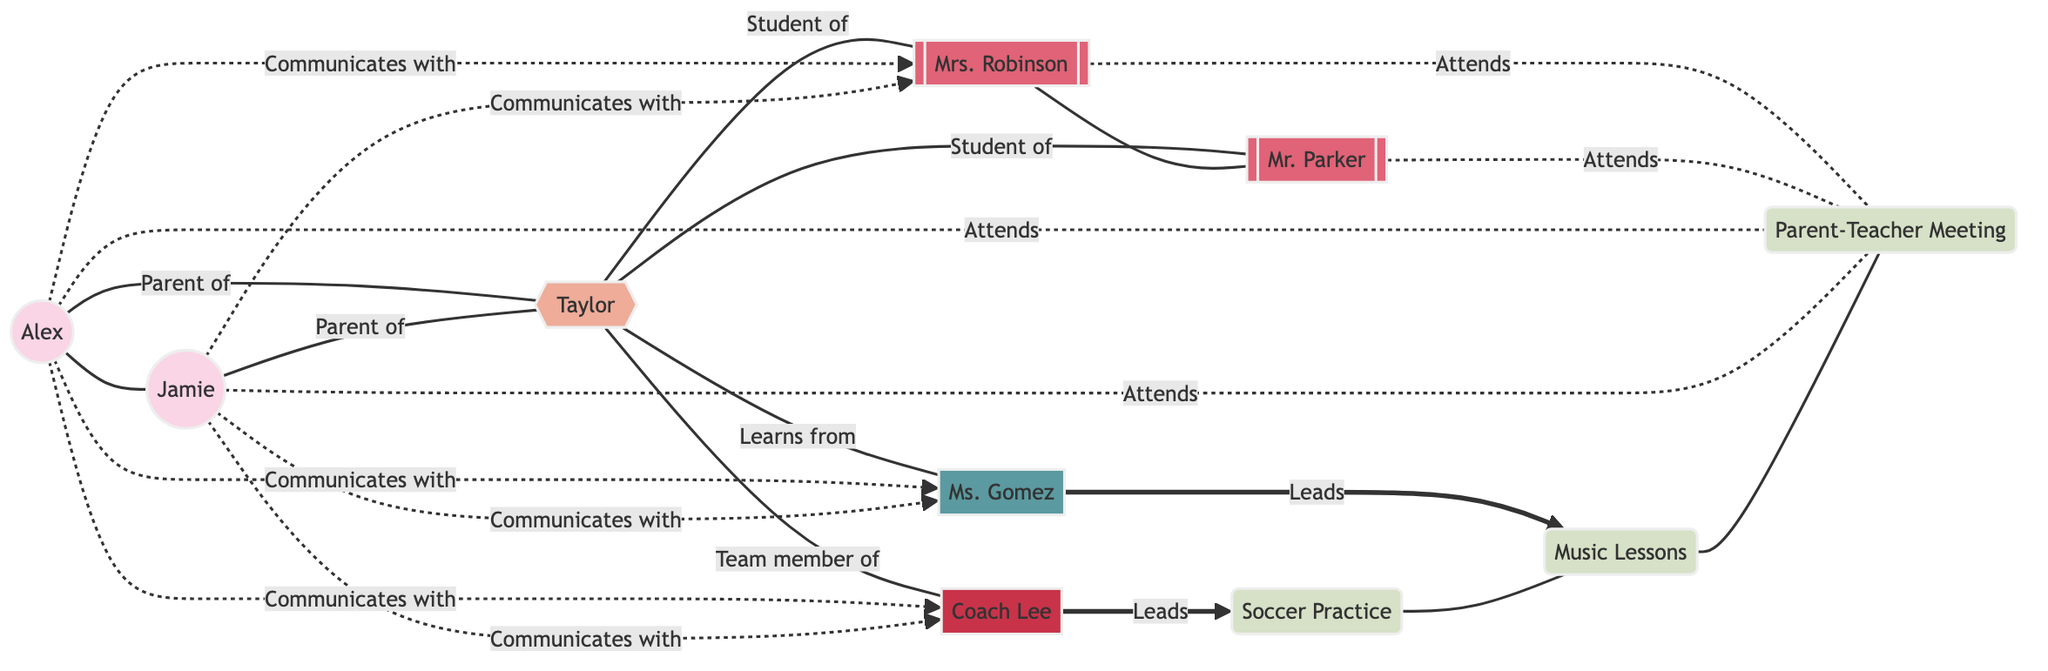What are the names of the two parents in the network? The diagram lists two parents: Alex and Jamie, who are the nodes representing parents in this support network.
Answer: Alex, Jamie How many teachers are involved in the network? The diagram shows two teachers: Mrs. Robinson and Mr. Parker, thus there are two nodes specifically labeled as teachers.
Answer: 2 Which child is represented in the diagram? The diagram features one node labeled as "Child: Taylor," indicating the single child involved in this support network.
Answer: Taylor Who leads the Soccer Practice activity? According to the diagram, "Coach Lee" is the individual shown as leading the Soccer Practice, which is directly linked to the coach node.
Answer: Coach Lee How many activities are represented in the diagram? The activities identified in the diagram include Soccer Practice, Music Lessons, and the Parent-Teacher Meeting, for a total of three distinct activity nodes.
Answer: 3 What is the relationship between Child: Taylor and Mrs. Robinson? The diagram indicates that Child: Taylor is a "Student of" Mrs. Robinson, representing the direct pedagogical connection between them.
Answer: Student of Which two parents communicate with the same music instructor? Both Alex and Jamie are shown in the diagram as communicating with "Ms. Gomez," the music instructor, establishing a shared connection.
Answer: Alex, Jamie How do the parents interact with the Parent-Teacher Meeting? The diagram shows both parents, Alex and Jamie, as attending the Parent-Teacher Meeting, indicating their active participation.
Answer: Attend Which activity does Coach Lee lead? The diagram distinctly specifies that Coach Lee is responsible for leading the "Soccer Practice" activity within the network.
Answer: Soccer Practice 